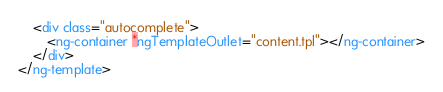Convert code to text. <code><loc_0><loc_0><loc_500><loc_500><_HTML_>	<div class="autocomplete">
		<ng-container *ngTemplateOutlet="content.tpl"></ng-container>
	</div>
</ng-template></code> 